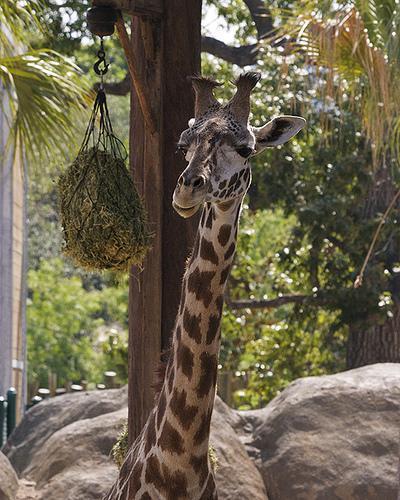How many horns does he have?
Give a very brief answer. 2. How many giraffes are here?
Give a very brief answer. 1. How many of the giraffe's ears can be seen?
Give a very brief answer. 1. How many animals are in the picture?
Give a very brief answer. 1. How many palm trees are shown?
Give a very brief answer. 2. 